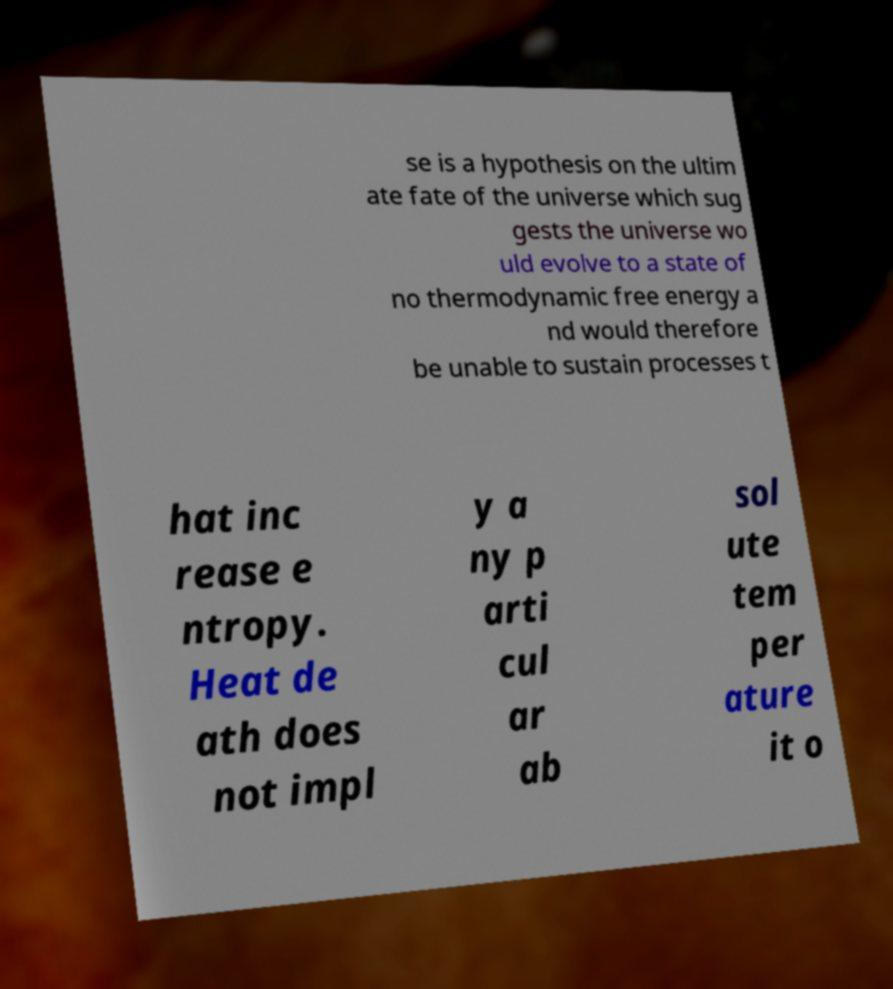Could you assist in decoding the text presented in this image and type it out clearly? se is a hypothesis on the ultim ate fate of the universe which sug gests the universe wo uld evolve to a state of no thermodynamic free energy a nd would therefore be unable to sustain processes t hat inc rease e ntropy. Heat de ath does not impl y a ny p arti cul ar ab sol ute tem per ature it o 